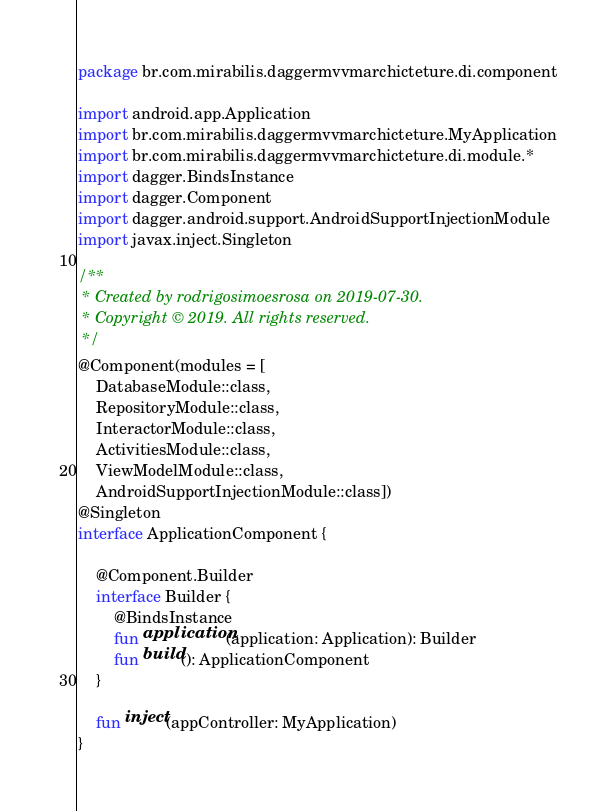Convert code to text. <code><loc_0><loc_0><loc_500><loc_500><_Kotlin_>package br.com.mirabilis.daggermvvmarchicteture.di.component

import android.app.Application
import br.com.mirabilis.daggermvvmarchicteture.MyApplication
import br.com.mirabilis.daggermvvmarchicteture.di.module.*
import dagger.BindsInstance
import dagger.Component
import dagger.android.support.AndroidSupportInjectionModule
import javax.inject.Singleton

/**
 * Created by rodrigosimoesrosa on 2019-07-30.
 * Copyright © 2019. All rights reserved.
 */
@Component(modules = [
    DatabaseModule::class,
    RepositoryModule::class,
    InteractorModule::class,
    ActivitiesModule::class,
    ViewModelModule::class,
    AndroidSupportInjectionModule::class])
@Singleton
interface ApplicationComponent {

    @Component.Builder
    interface Builder {
        @BindsInstance
        fun application(application: Application): Builder
        fun build(): ApplicationComponent
    }

    fun inject(appController: MyApplication)
}
</code> 